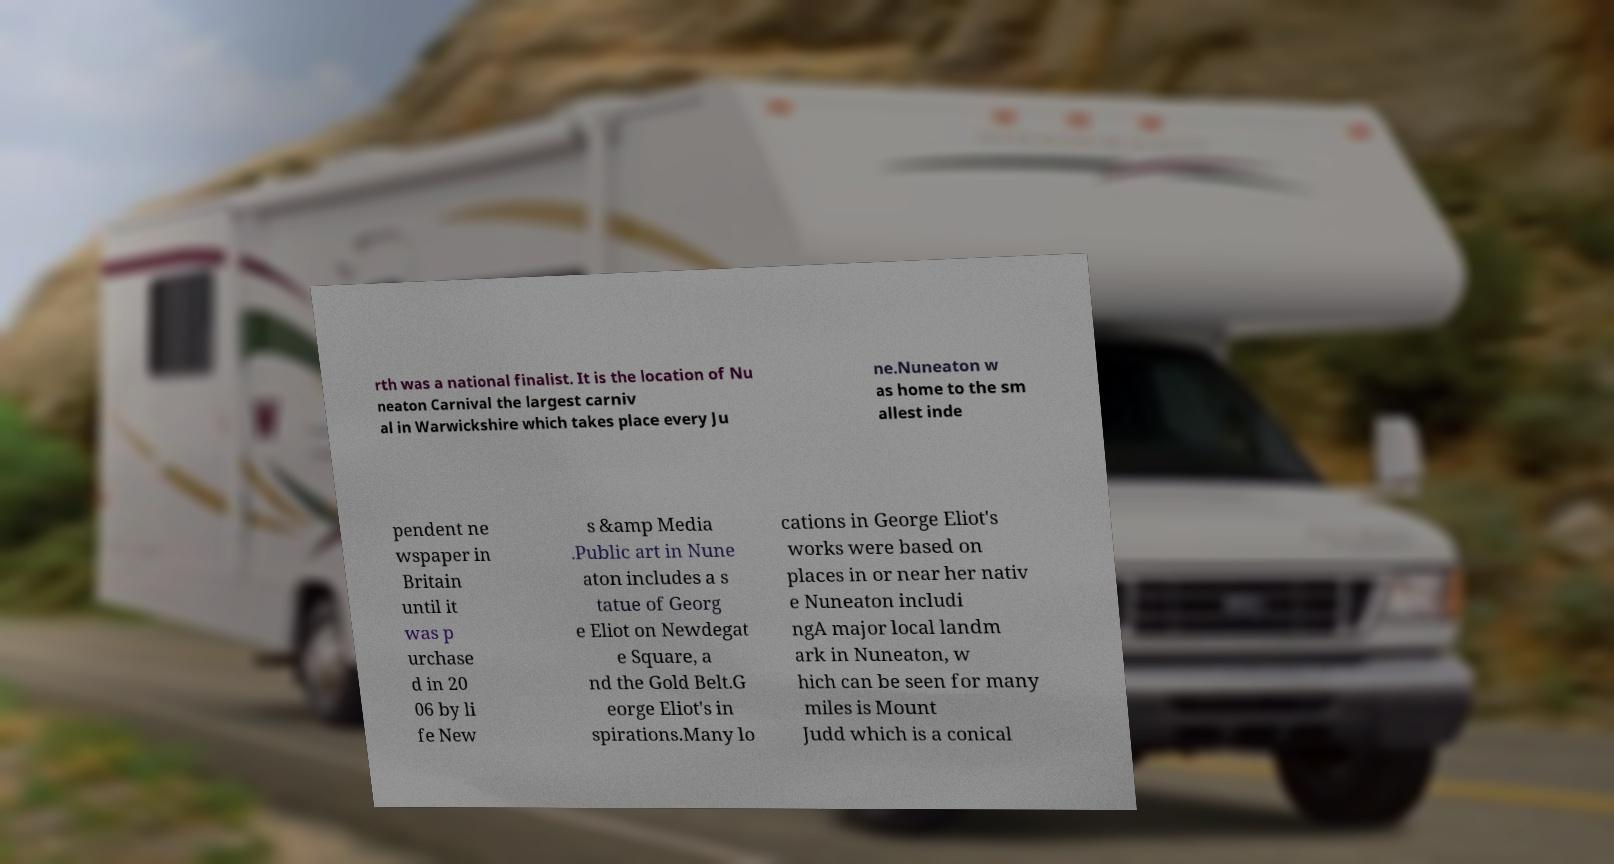Can you read and provide the text displayed in the image?This photo seems to have some interesting text. Can you extract and type it out for me? rth was a national finalist. It is the location of Nu neaton Carnival the largest carniv al in Warwickshire which takes place every Ju ne.Nuneaton w as home to the sm allest inde pendent ne wspaper in Britain until it was p urchase d in 20 06 by li fe New s &amp Media .Public art in Nune aton includes a s tatue of Georg e Eliot on Newdegat e Square, a nd the Gold Belt.G eorge Eliot's in spirations.Many lo cations in George Eliot's works were based on places in or near her nativ e Nuneaton includi ngA major local landm ark in Nuneaton, w hich can be seen for many miles is Mount Judd which is a conical 